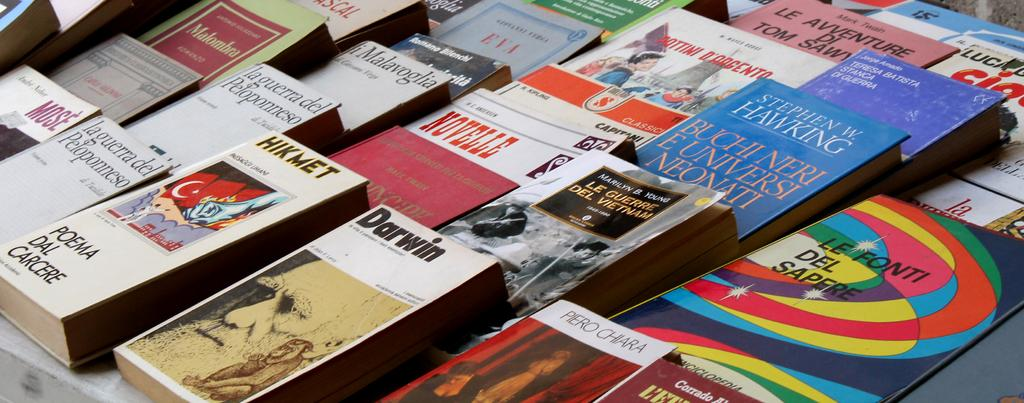<image>
Share a concise interpretation of the image provided. A collection of books including one written by Stephen Hawking. 